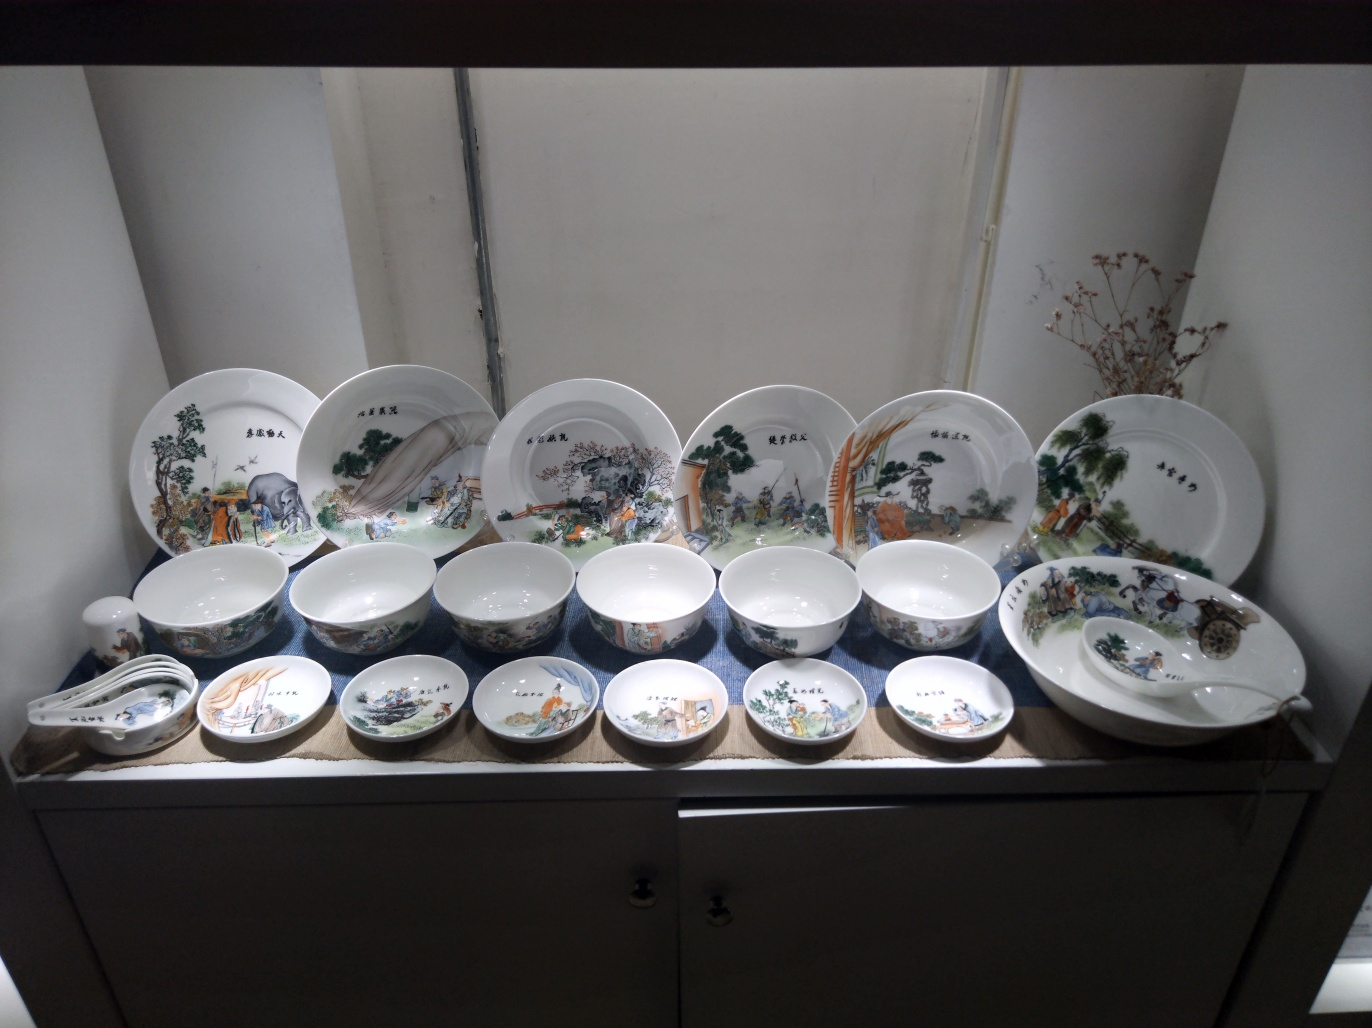Can you describe the patterns on the dishware? The dishware features detailed pastoral scenes, including landscapes, animals, and people engaging in various activities. There is a sense of life and vibrancy in each scene, with flora and fauna depicted in a realistic fashion. Some items showcase larger, central tableaux, while others depict smaller, more focused vignettes. The color palette is traditional, consisting primarily of blues, greens, whites, and browns, which adds to the classical charm of the collection. 